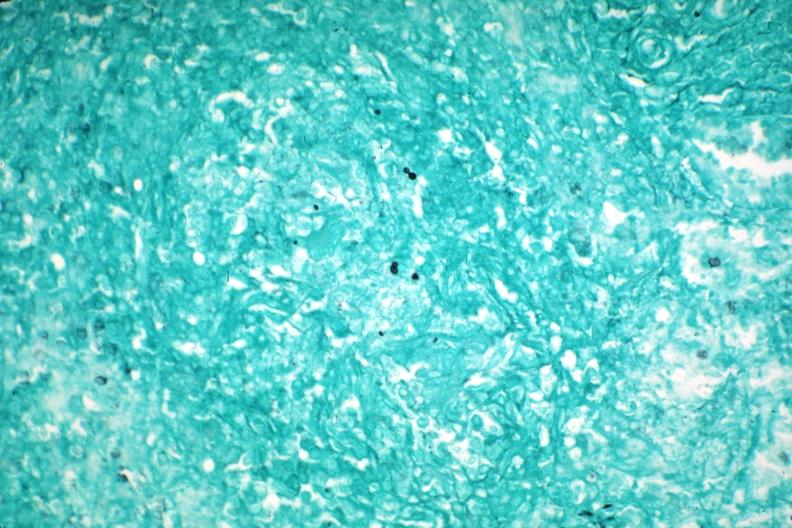s close-up tumor present?
Answer the question using a single word or phrase. No 